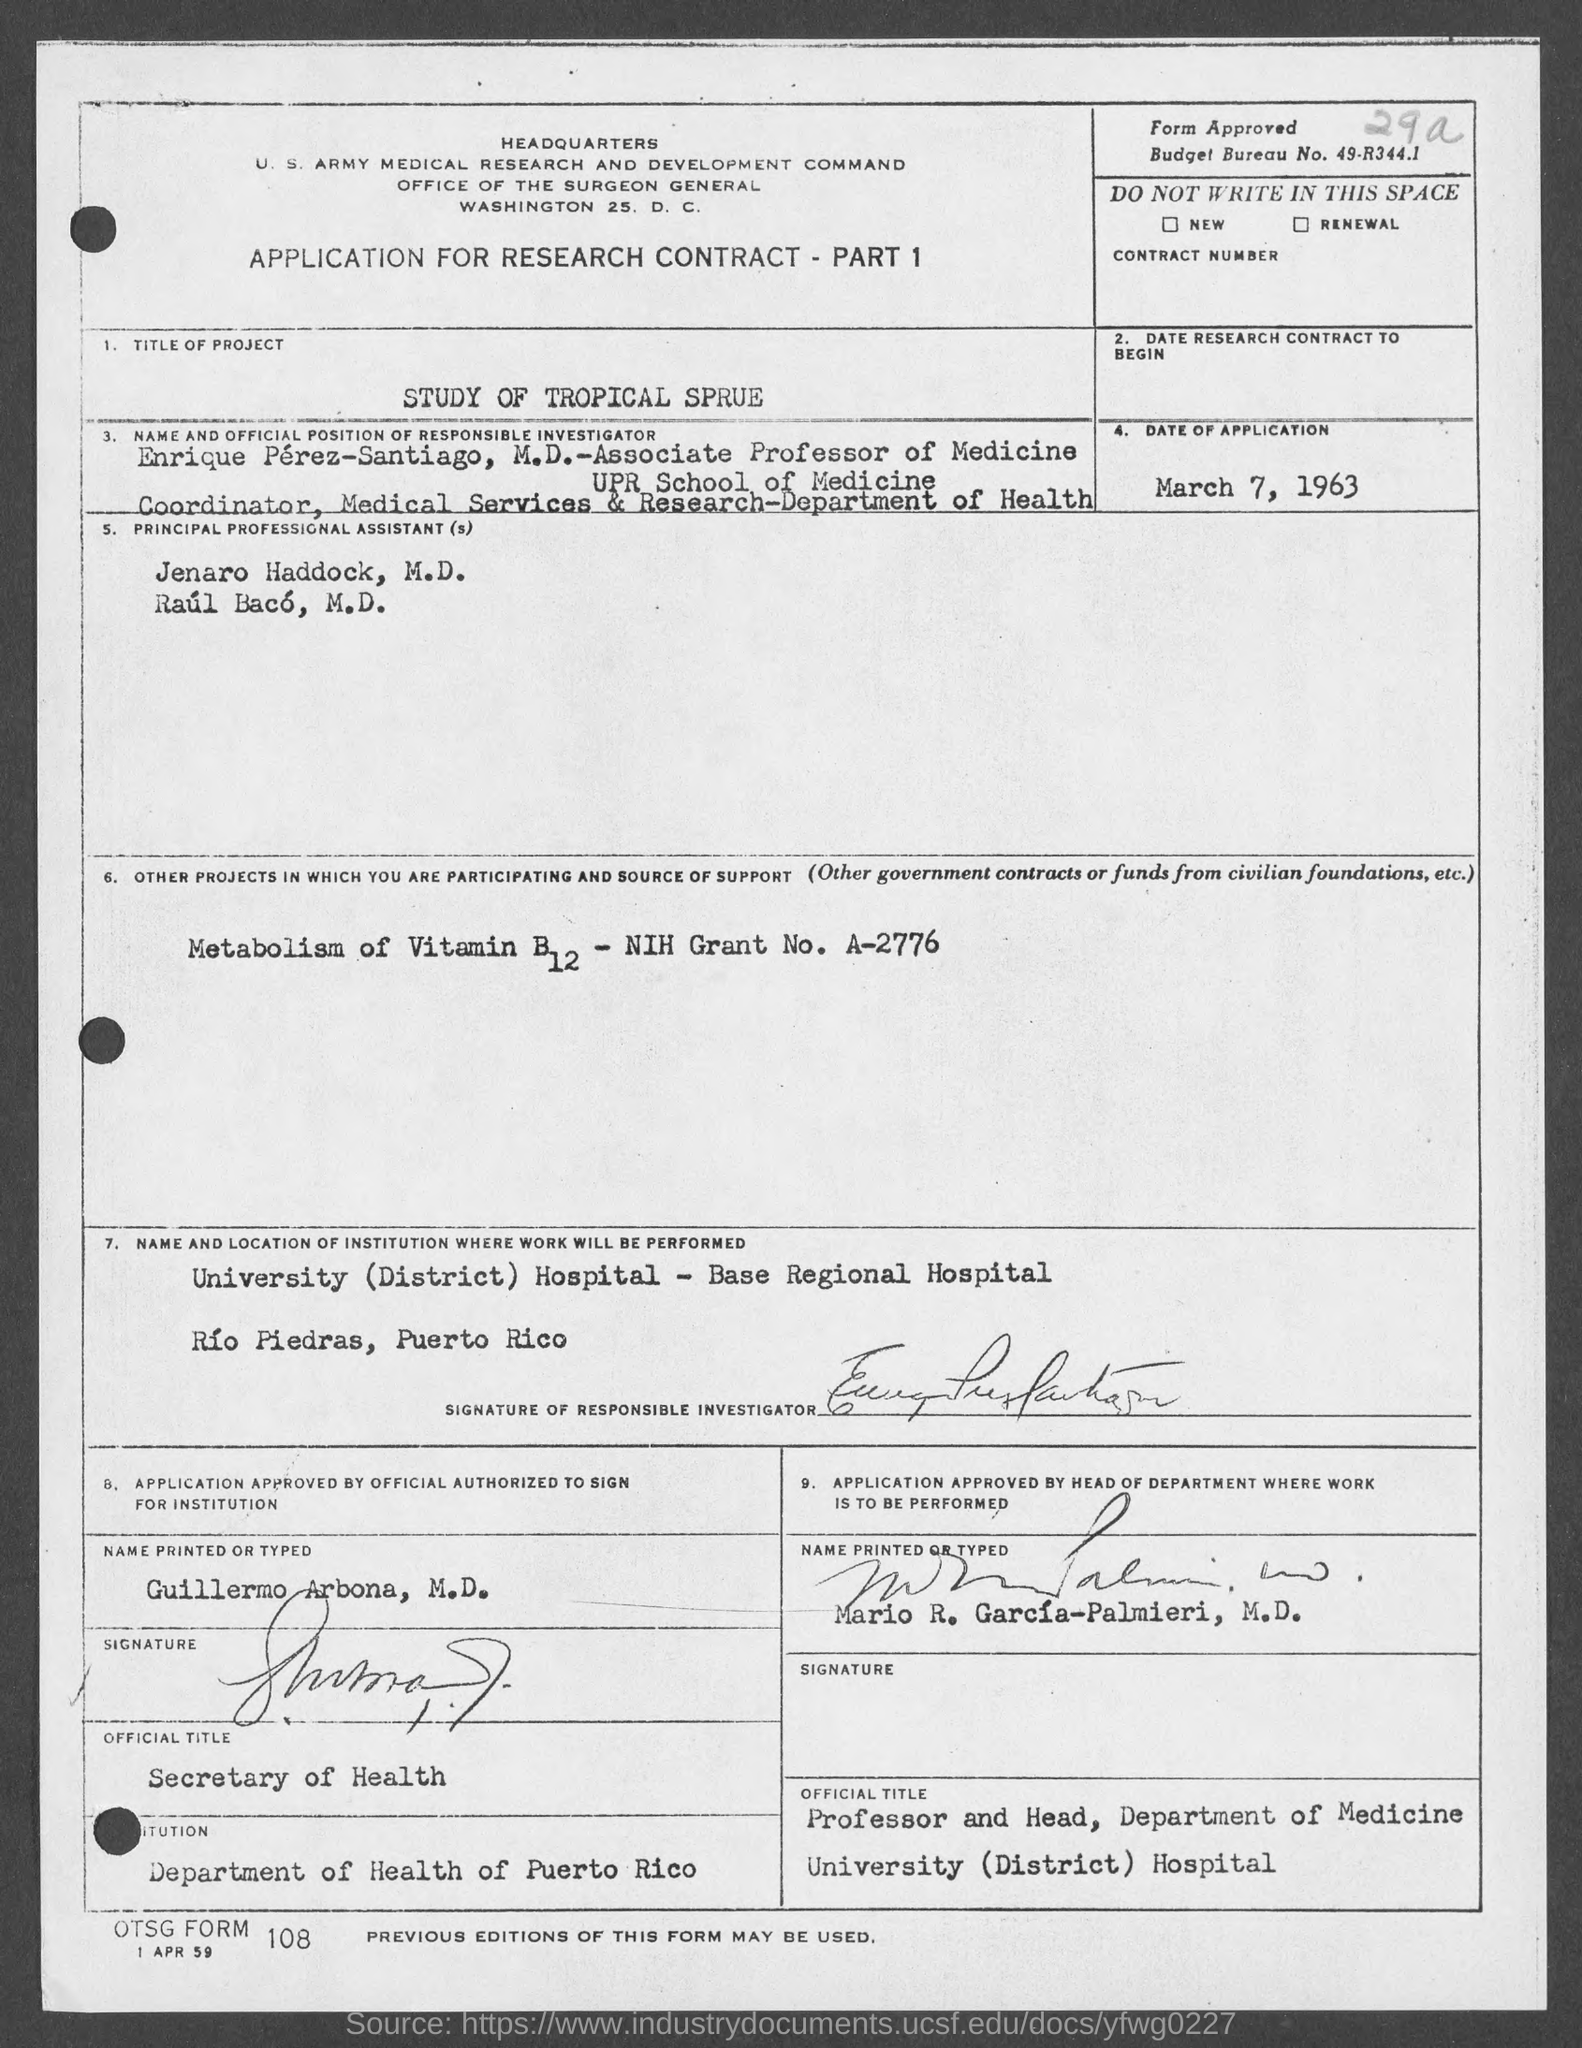Specify some key components in this picture. The title of the project is a study of tropical sprue. The budget bureau number is 49-R344.1. Guillermo Arbona, M.D. is the Secretary of Health. 